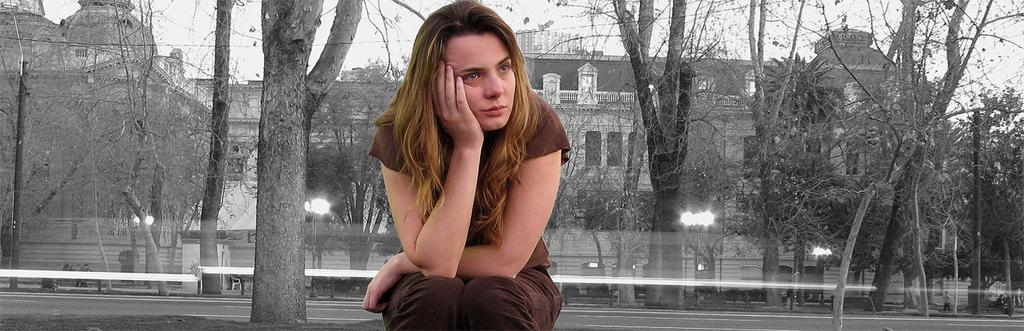Who is present in the image? There is a person in the image. What is the person wearing? The person is wearing a brown dress. What can be seen in the background of the image? There are buildings, trees, light poles, and the sky visible in the background of the image. Is the person in the image making a request to the light poles? There is no indication in the image that the person is making a request to the light poles, as their actions or expressions are not visible. 